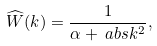<formula> <loc_0><loc_0><loc_500><loc_500>\widehat { W } ( k ) & = \frac { 1 } { \alpha + \ a b s { k } ^ { 2 } } ,</formula> 